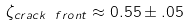Convert formula to latex. <formula><loc_0><loc_0><loc_500><loc_500>\zeta _ { c r a c k \ f r o n t } \approx 0 . 5 5 \pm . 0 5</formula> 